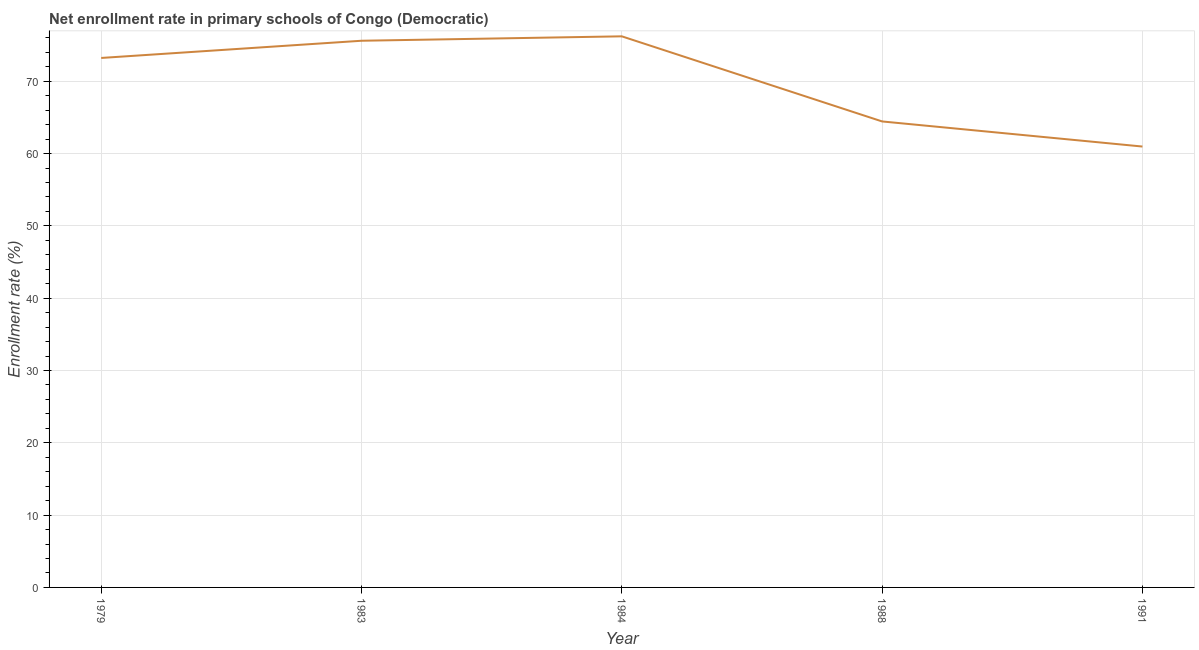What is the net enrollment rate in primary schools in 1991?
Your answer should be very brief. 60.97. Across all years, what is the maximum net enrollment rate in primary schools?
Provide a succinct answer. 76.21. Across all years, what is the minimum net enrollment rate in primary schools?
Ensure brevity in your answer.  60.97. In which year was the net enrollment rate in primary schools maximum?
Give a very brief answer. 1984. What is the sum of the net enrollment rate in primary schools?
Give a very brief answer. 350.43. What is the difference between the net enrollment rate in primary schools in 1979 and 1984?
Offer a very short reply. -2.99. What is the average net enrollment rate in primary schools per year?
Give a very brief answer. 70.09. What is the median net enrollment rate in primary schools?
Offer a terse response. 73.22. In how many years, is the net enrollment rate in primary schools greater than 30 %?
Provide a succinct answer. 5. Do a majority of the years between 1979 and 1988 (inclusive) have net enrollment rate in primary schools greater than 8 %?
Ensure brevity in your answer.  Yes. What is the ratio of the net enrollment rate in primary schools in 1979 to that in 1988?
Provide a succinct answer. 1.14. Is the net enrollment rate in primary schools in 1983 less than that in 1988?
Offer a terse response. No. Is the difference between the net enrollment rate in primary schools in 1983 and 1984 greater than the difference between any two years?
Give a very brief answer. No. What is the difference between the highest and the second highest net enrollment rate in primary schools?
Give a very brief answer. 0.61. What is the difference between the highest and the lowest net enrollment rate in primary schools?
Give a very brief answer. 15.24. In how many years, is the net enrollment rate in primary schools greater than the average net enrollment rate in primary schools taken over all years?
Your answer should be very brief. 3. How many lines are there?
Give a very brief answer. 1. Does the graph contain any zero values?
Offer a terse response. No. Does the graph contain grids?
Offer a terse response. Yes. What is the title of the graph?
Provide a succinct answer. Net enrollment rate in primary schools of Congo (Democratic). What is the label or title of the X-axis?
Give a very brief answer. Year. What is the label or title of the Y-axis?
Provide a succinct answer. Enrollment rate (%). What is the Enrollment rate (%) of 1979?
Keep it short and to the point. 73.22. What is the Enrollment rate (%) in 1983?
Ensure brevity in your answer.  75.6. What is the Enrollment rate (%) of 1984?
Give a very brief answer. 76.21. What is the Enrollment rate (%) of 1988?
Offer a very short reply. 64.44. What is the Enrollment rate (%) of 1991?
Offer a terse response. 60.97. What is the difference between the Enrollment rate (%) in 1979 and 1983?
Your answer should be compact. -2.38. What is the difference between the Enrollment rate (%) in 1979 and 1984?
Ensure brevity in your answer.  -2.99. What is the difference between the Enrollment rate (%) in 1979 and 1988?
Ensure brevity in your answer.  8.78. What is the difference between the Enrollment rate (%) in 1979 and 1991?
Ensure brevity in your answer.  12.25. What is the difference between the Enrollment rate (%) in 1983 and 1984?
Your answer should be very brief. -0.61. What is the difference between the Enrollment rate (%) in 1983 and 1988?
Offer a very short reply. 11.16. What is the difference between the Enrollment rate (%) in 1983 and 1991?
Your answer should be very brief. 14.63. What is the difference between the Enrollment rate (%) in 1984 and 1988?
Ensure brevity in your answer.  11.77. What is the difference between the Enrollment rate (%) in 1984 and 1991?
Provide a short and direct response. 15.24. What is the difference between the Enrollment rate (%) in 1988 and 1991?
Your answer should be compact. 3.47. What is the ratio of the Enrollment rate (%) in 1979 to that in 1983?
Give a very brief answer. 0.97. What is the ratio of the Enrollment rate (%) in 1979 to that in 1984?
Your response must be concise. 0.96. What is the ratio of the Enrollment rate (%) in 1979 to that in 1988?
Make the answer very short. 1.14. What is the ratio of the Enrollment rate (%) in 1979 to that in 1991?
Your response must be concise. 1.2. What is the ratio of the Enrollment rate (%) in 1983 to that in 1984?
Make the answer very short. 0.99. What is the ratio of the Enrollment rate (%) in 1983 to that in 1988?
Offer a very short reply. 1.17. What is the ratio of the Enrollment rate (%) in 1983 to that in 1991?
Offer a very short reply. 1.24. What is the ratio of the Enrollment rate (%) in 1984 to that in 1988?
Offer a terse response. 1.18. What is the ratio of the Enrollment rate (%) in 1988 to that in 1991?
Provide a short and direct response. 1.06. 